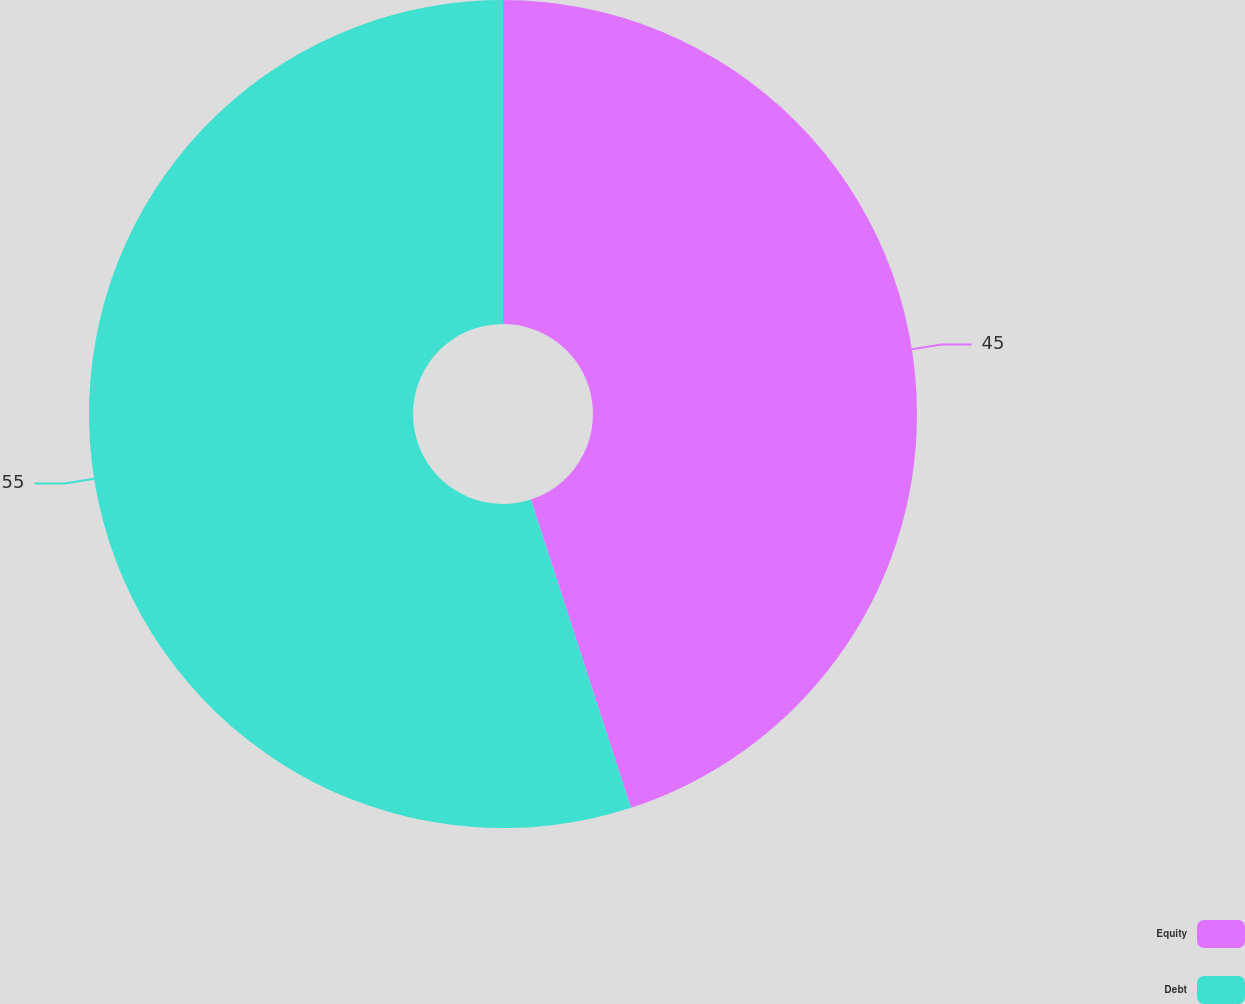<chart> <loc_0><loc_0><loc_500><loc_500><pie_chart><fcel>Equity<fcel>Debt<nl><fcel>45.0%<fcel>55.0%<nl></chart> 